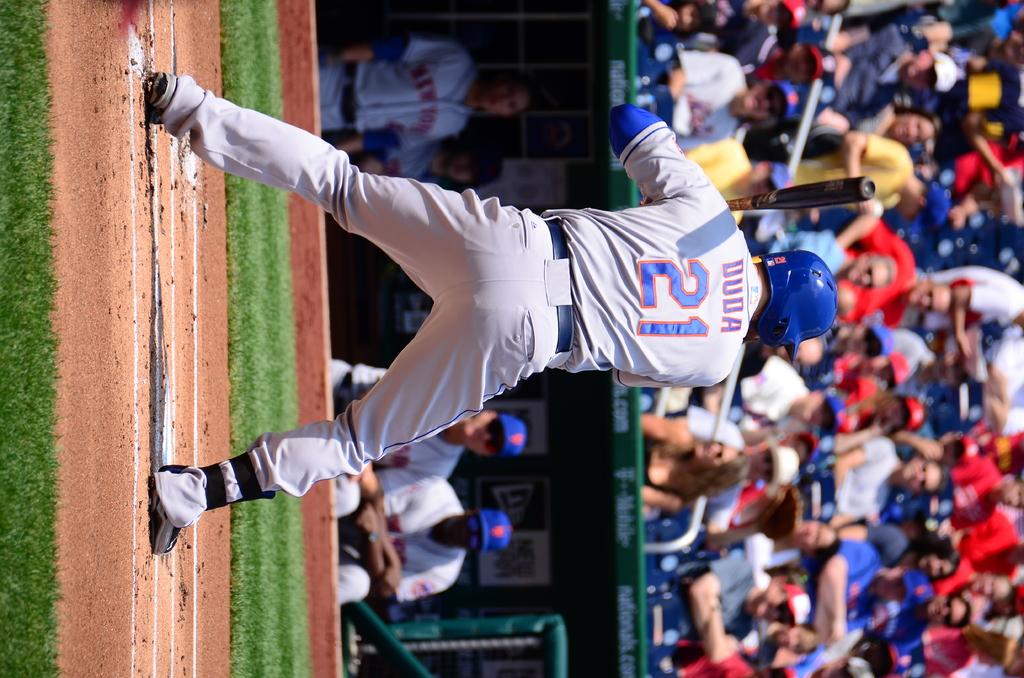<image>
Share a concise interpretation of the image provided. A baseball player named Duda awaits the pitch at home plate while other members of the team observe from the dugout. 